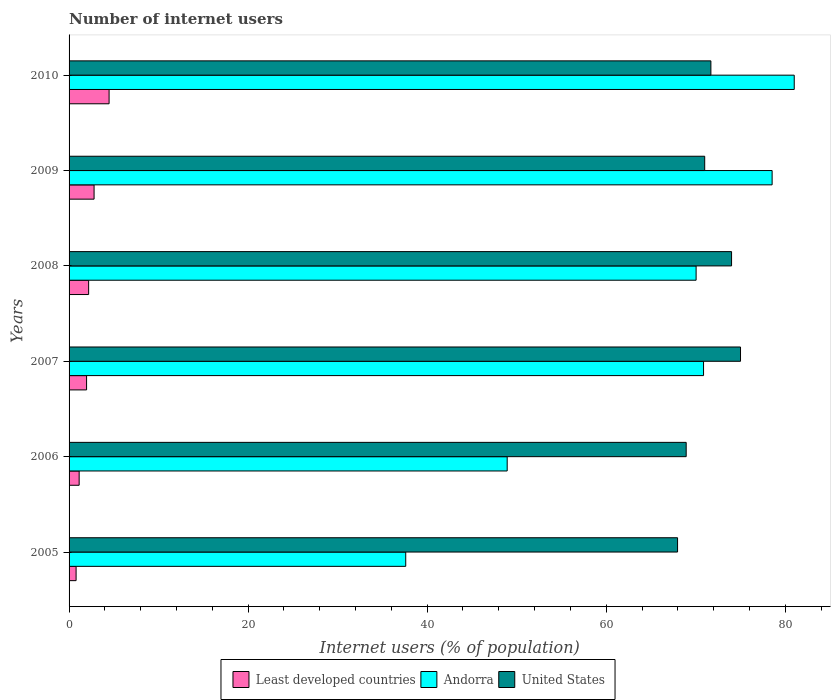Are the number of bars on each tick of the Y-axis equal?
Make the answer very short. Yes. How many bars are there on the 4th tick from the top?
Offer a very short reply. 3. How many bars are there on the 6th tick from the bottom?
Make the answer very short. 3. What is the label of the 6th group of bars from the top?
Provide a succinct answer. 2005. What is the number of internet users in Andorra in 2010?
Ensure brevity in your answer.  81. Across all years, what is the minimum number of internet users in Andorra?
Give a very brief answer. 37.61. What is the total number of internet users in United States in the graph?
Offer a very short reply. 428.59. What is the difference between the number of internet users in United States in 2006 and that in 2009?
Your answer should be compact. -2.07. What is the difference between the number of internet users in United States in 2010 and the number of internet users in Andorra in 2006?
Your answer should be compact. 22.75. What is the average number of internet users in Andorra per year?
Keep it short and to the point. 64.5. In the year 2008, what is the difference between the number of internet users in Andorra and number of internet users in United States?
Ensure brevity in your answer.  -3.96. In how many years, is the number of internet users in Andorra greater than 56 %?
Your answer should be very brief. 4. What is the ratio of the number of internet users in United States in 2009 to that in 2010?
Your answer should be very brief. 0.99. Is the difference between the number of internet users in Andorra in 2005 and 2010 greater than the difference between the number of internet users in United States in 2005 and 2010?
Keep it short and to the point. No. What is the difference between the highest and the lowest number of internet users in United States?
Provide a short and direct response. 7.03. In how many years, is the number of internet users in Andorra greater than the average number of internet users in Andorra taken over all years?
Provide a succinct answer. 4. Is the sum of the number of internet users in Least developed countries in 2007 and 2009 greater than the maximum number of internet users in Andorra across all years?
Give a very brief answer. No. What does the 2nd bar from the top in 2009 represents?
Make the answer very short. Andorra. What does the 1st bar from the bottom in 2007 represents?
Make the answer very short. Least developed countries. Are all the bars in the graph horizontal?
Make the answer very short. Yes. What is the difference between two consecutive major ticks on the X-axis?
Keep it short and to the point. 20. Are the values on the major ticks of X-axis written in scientific E-notation?
Your answer should be compact. No. Does the graph contain grids?
Give a very brief answer. No. Where does the legend appear in the graph?
Keep it short and to the point. Bottom center. How many legend labels are there?
Offer a terse response. 3. What is the title of the graph?
Provide a short and direct response. Number of internet users. What is the label or title of the X-axis?
Offer a very short reply. Internet users (% of population). What is the Internet users (% of population) in Least developed countries in 2005?
Provide a short and direct response. 0.78. What is the Internet users (% of population) of Andorra in 2005?
Provide a succinct answer. 37.61. What is the Internet users (% of population) of United States in 2005?
Ensure brevity in your answer.  67.97. What is the Internet users (% of population) in Least developed countries in 2006?
Your answer should be very brief. 1.13. What is the Internet users (% of population) in Andorra in 2006?
Your response must be concise. 48.94. What is the Internet users (% of population) in United States in 2006?
Make the answer very short. 68.93. What is the Internet users (% of population) in Least developed countries in 2007?
Keep it short and to the point. 1.96. What is the Internet users (% of population) in Andorra in 2007?
Offer a very short reply. 70.87. What is the Internet users (% of population) in Least developed countries in 2008?
Your response must be concise. 2.19. What is the Internet users (% of population) of Andorra in 2008?
Give a very brief answer. 70.04. What is the Internet users (% of population) of Least developed countries in 2009?
Offer a very short reply. 2.79. What is the Internet users (% of population) in Andorra in 2009?
Ensure brevity in your answer.  78.53. What is the Internet users (% of population) of United States in 2009?
Offer a very short reply. 71. What is the Internet users (% of population) in Least developed countries in 2010?
Your answer should be compact. 4.47. What is the Internet users (% of population) in United States in 2010?
Provide a short and direct response. 71.69. Across all years, what is the maximum Internet users (% of population) of Least developed countries?
Offer a terse response. 4.47. Across all years, what is the maximum Internet users (% of population) of Andorra?
Provide a short and direct response. 81. Across all years, what is the minimum Internet users (% of population) of Least developed countries?
Keep it short and to the point. 0.78. Across all years, what is the minimum Internet users (% of population) of Andorra?
Offer a very short reply. 37.61. Across all years, what is the minimum Internet users (% of population) in United States?
Offer a terse response. 67.97. What is the total Internet users (% of population) of Least developed countries in the graph?
Your answer should be compact. 13.32. What is the total Internet users (% of population) of Andorra in the graph?
Offer a terse response. 386.98. What is the total Internet users (% of population) of United States in the graph?
Your answer should be very brief. 428.59. What is the difference between the Internet users (% of population) of Least developed countries in 2005 and that in 2006?
Offer a terse response. -0.34. What is the difference between the Internet users (% of population) in Andorra in 2005 and that in 2006?
Offer a very short reply. -11.33. What is the difference between the Internet users (% of population) in United States in 2005 and that in 2006?
Your answer should be compact. -0.96. What is the difference between the Internet users (% of population) in Least developed countries in 2005 and that in 2007?
Give a very brief answer. -1.17. What is the difference between the Internet users (% of population) in Andorra in 2005 and that in 2007?
Ensure brevity in your answer.  -33.26. What is the difference between the Internet users (% of population) of United States in 2005 and that in 2007?
Give a very brief answer. -7.03. What is the difference between the Internet users (% of population) of Least developed countries in 2005 and that in 2008?
Offer a terse response. -1.4. What is the difference between the Internet users (% of population) in Andorra in 2005 and that in 2008?
Provide a short and direct response. -32.43. What is the difference between the Internet users (% of population) of United States in 2005 and that in 2008?
Ensure brevity in your answer.  -6.03. What is the difference between the Internet users (% of population) of Least developed countries in 2005 and that in 2009?
Offer a terse response. -2.01. What is the difference between the Internet users (% of population) in Andorra in 2005 and that in 2009?
Keep it short and to the point. -40.92. What is the difference between the Internet users (% of population) of United States in 2005 and that in 2009?
Make the answer very short. -3.03. What is the difference between the Internet users (% of population) of Least developed countries in 2005 and that in 2010?
Keep it short and to the point. -3.69. What is the difference between the Internet users (% of population) of Andorra in 2005 and that in 2010?
Your response must be concise. -43.39. What is the difference between the Internet users (% of population) in United States in 2005 and that in 2010?
Ensure brevity in your answer.  -3.72. What is the difference between the Internet users (% of population) of Least developed countries in 2006 and that in 2007?
Provide a short and direct response. -0.83. What is the difference between the Internet users (% of population) of Andorra in 2006 and that in 2007?
Give a very brief answer. -21.93. What is the difference between the Internet users (% of population) of United States in 2006 and that in 2007?
Your response must be concise. -6.07. What is the difference between the Internet users (% of population) of Least developed countries in 2006 and that in 2008?
Offer a very short reply. -1.06. What is the difference between the Internet users (% of population) of Andorra in 2006 and that in 2008?
Your answer should be compact. -21.1. What is the difference between the Internet users (% of population) of United States in 2006 and that in 2008?
Offer a very short reply. -5.07. What is the difference between the Internet users (% of population) of Least developed countries in 2006 and that in 2009?
Offer a very short reply. -1.67. What is the difference between the Internet users (% of population) of Andorra in 2006 and that in 2009?
Your answer should be very brief. -29.59. What is the difference between the Internet users (% of population) of United States in 2006 and that in 2009?
Provide a short and direct response. -2.07. What is the difference between the Internet users (% of population) in Least developed countries in 2006 and that in 2010?
Ensure brevity in your answer.  -3.34. What is the difference between the Internet users (% of population) in Andorra in 2006 and that in 2010?
Your answer should be compact. -32.06. What is the difference between the Internet users (% of population) in United States in 2006 and that in 2010?
Provide a short and direct response. -2.76. What is the difference between the Internet users (% of population) in Least developed countries in 2007 and that in 2008?
Your response must be concise. -0.23. What is the difference between the Internet users (% of population) in Andorra in 2007 and that in 2008?
Provide a succinct answer. 0.83. What is the difference between the Internet users (% of population) in Least developed countries in 2007 and that in 2009?
Provide a succinct answer. -0.84. What is the difference between the Internet users (% of population) of Andorra in 2007 and that in 2009?
Your answer should be very brief. -7.66. What is the difference between the Internet users (% of population) in Least developed countries in 2007 and that in 2010?
Offer a very short reply. -2.52. What is the difference between the Internet users (% of population) in Andorra in 2007 and that in 2010?
Make the answer very short. -10.13. What is the difference between the Internet users (% of population) in United States in 2007 and that in 2010?
Offer a terse response. 3.31. What is the difference between the Internet users (% of population) of Least developed countries in 2008 and that in 2009?
Give a very brief answer. -0.61. What is the difference between the Internet users (% of population) of Andorra in 2008 and that in 2009?
Offer a terse response. -8.49. What is the difference between the Internet users (% of population) of Least developed countries in 2008 and that in 2010?
Provide a succinct answer. -2.29. What is the difference between the Internet users (% of population) in Andorra in 2008 and that in 2010?
Your answer should be compact. -10.96. What is the difference between the Internet users (% of population) in United States in 2008 and that in 2010?
Make the answer very short. 2.31. What is the difference between the Internet users (% of population) of Least developed countries in 2009 and that in 2010?
Ensure brevity in your answer.  -1.68. What is the difference between the Internet users (% of population) in Andorra in 2009 and that in 2010?
Keep it short and to the point. -2.47. What is the difference between the Internet users (% of population) of United States in 2009 and that in 2010?
Give a very brief answer. -0.69. What is the difference between the Internet users (% of population) of Least developed countries in 2005 and the Internet users (% of population) of Andorra in 2006?
Keep it short and to the point. -48.15. What is the difference between the Internet users (% of population) of Least developed countries in 2005 and the Internet users (% of population) of United States in 2006?
Provide a succinct answer. -68.15. What is the difference between the Internet users (% of population) of Andorra in 2005 and the Internet users (% of population) of United States in 2006?
Your answer should be compact. -31.33. What is the difference between the Internet users (% of population) in Least developed countries in 2005 and the Internet users (% of population) in Andorra in 2007?
Your response must be concise. -70.09. What is the difference between the Internet users (% of population) of Least developed countries in 2005 and the Internet users (% of population) of United States in 2007?
Keep it short and to the point. -74.22. What is the difference between the Internet users (% of population) in Andorra in 2005 and the Internet users (% of population) in United States in 2007?
Your response must be concise. -37.39. What is the difference between the Internet users (% of population) in Least developed countries in 2005 and the Internet users (% of population) in Andorra in 2008?
Make the answer very short. -69.26. What is the difference between the Internet users (% of population) in Least developed countries in 2005 and the Internet users (% of population) in United States in 2008?
Ensure brevity in your answer.  -73.22. What is the difference between the Internet users (% of population) of Andorra in 2005 and the Internet users (% of population) of United States in 2008?
Provide a succinct answer. -36.39. What is the difference between the Internet users (% of population) of Least developed countries in 2005 and the Internet users (% of population) of Andorra in 2009?
Offer a very short reply. -77.75. What is the difference between the Internet users (% of population) in Least developed countries in 2005 and the Internet users (% of population) in United States in 2009?
Give a very brief answer. -70.22. What is the difference between the Internet users (% of population) of Andorra in 2005 and the Internet users (% of population) of United States in 2009?
Give a very brief answer. -33.39. What is the difference between the Internet users (% of population) of Least developed countries in 2005 and the Internet users (% of population) of Andorra in 2010?
Keep it short and to the point. -80.22. What is the difference between the Internet users (% of population) of Least developed countries in 2005 and the Internet users (% of population) of United States in 2010?
Provide a short and direct response. -70.91. What is the difference between the Internet users (% of population) of Andorra in 2005 and the Internet users (% of population) of United States in 2010?
Your answer should be compact. -34.08. What is the difference between the Internet users (% of population) in Least developed countries in 2006 and the Internet users (% of population) in Andorra in 2007?
Your response must be concise. -69.74. What is the difference between the Internet users (% of population) in Least developed countries in 2006 and the Internet users (% of population) in United States in 2007?
Your answer should be compact. -73.87. What is the difference between the Internet users (% of population) in Andorra in 2006 and the Internet users (% of population) in United States in 2007?
Keep it short and to the point. -26.06. What is the difference between the Internet users (% of population) in Least developed countries in 2006 and the Internet users (% of population) in Andorra in 2008?
Your answer should be very brief. -68.91. What is the difference between the Internet users (% of population) of Least developed countries in 2006 and the Internet users (% of population) of United States in 2008?
Provide a short and direct response. -72.87. What is the difference between the Internet users (% of population) of Andorra in 2006 and the Internet users (% of population) of United States in 2008?
Keep it short and to the point. -25.06. What is the difference between the Internet users (% of population) in Least developed countries in 2006 and the Internet users (% of population) in Andorra in 2009?
Provide a succinct answer. -77.4. What is the difference between the Internet users (% of population) of Least developed countries in 2006 and the Internet users (% of population) of United States in 2009?
Give a very brief answer. -69.87. What is the difference between the Internet users (% of population) in Andorra in 2006 and the Internet users (% of population) in United States in 2009?
Provide a short and direct response. -22.06. What is the difference between the Internet users (% of population) of Least developed countries in 2006 and the Internet users (% of population) of Andorra in 2010?
Offer a terse response. -79.87. What is the difference between the Internet users (% of population) in Least developed countries in 2006 and the Internet users (% of population) in United States in 2010?
Offer a very short reply. -70.56. What is the difference between the Internet users (% of population) in Andorra in 2006 and the Internet users (% of population) in United States in 2010?
Ensure brevity in your answer.  -22.75. What is the difference between the Internet users (% of population) in Least developed countries in 2007 and the Internet users (% of population) in Andorra in 2008?
Give a very brief answer. -68.08. What is the difference between the Internet users (% of population) of Least developed countries in 2007 and the Internet users (% of population) of United States in 2008?
Your answer should be very brief. -72.04. What is the difference between the Internet users (% of population) in Andorra in 2007 and the Internet users (% of population) in United States in 2008?
Provide a short and direct response. -3.13. What is the difference between the Internet users (% of population) in Least developed countries in 2007 and the Internet users (% of population) in Andorra in 2009?
Provide a succinct answer. -76.57. What is the difference between the Internet users (% of population) of Least developed countries in 2007 and the Internet users (% of population) of United States in 2009?
Offer a very short reply. -69.04. What is the difference between the Internet users (% of population) in Andorra in 2007 and the Internet users (% of population) in United States in 2009?
Your answer should be very brief. -0.13. What is the difference between the Internet users (% of population) of Least developed countries in 2007 and the Internet users (% of population) of Andorra in 2010?
Keep it short and to the point. -79.04. What is the difference between the Internet users (% of population) in Least developed countries in 2007 and the Internet users (% of population) in United States in 2010?
Your answer should be very brief. -69.73. What is the difference between the Internet users (% of population) in Andorra in 2007 and the Internet users (% of population) in United States in 2010?
Offer a terse response. -0.82. What is the difference between the Internet users (% of population) of Least developed countries in 2008 and the Internet users (% of population) of Andorra in 2009?
Your answer should be compact. -76.34. What is the difference between the Internet users (% of population) in Least developed countries in 2008 and the Internet users (% of population) in United States in 2009?
Your response must be concise. -68.81. What is the difference between the Internet users (% of population) in Andorra in 2008 and the Internet users (% of population) in United States in 2009?
Provide a short and direct response. -0.96. What is the difference between the Internet users (% of population) of Least developed countries in 2008 and the Internet users (% of population) of Andorra in 2010?
Your answer should be very brief. -78.81. What is the difference between the Internet users (% of population) of Least developed countries in 2008 and the Internet users (% of population) of United States in 2010?
Your response must be concise. -69.5. What is the difference between the Internet users (% of population) in Andorra in 2008 and the Internet users (% of population) in United States in 2010?
Ensure brevity in your answer.  -1.65. What is the difference between the Internet users (% of population) in Least developed countries in 2009 and the Internet users (% of population) in Andorra in 2010?
Your response must be concise. -78.21. What is the difference between the Internet users (% of population) in Least developed countries in 2009 and the Internet users (% of population) in United States in 2010?
Your answer should be very brief. -68.9. What is the difference between the Internet users (% of population) in Andorra in 2009 and the Internet users (% of population) in United States in 2010?
Your answer should be compact. 6.84. What is the average Internet users (% of population) of Least developed countries per year?
Ensure brevity in your answer.  2.22. What is the average Internet users (% of population) in Andorra per year?
Provide a short and direct response. 64.5. What is the average Internet users (% of population) in United States per year?
Your answer should be very brief. 71.43. In the year 2005, what is the difference between the Internet users (% of population) of Least developed countries and Internet users (% of population) of Andorra?
Ensure brevity in your answer.  -36.82. In the year 2005, what is the difference between the Internet users (% of population) in Least developed countries and Internet users (% of population) in United States?
Provide a succinct answer. -67.18. In the year 2005, what is the difference between the Internet users (% of population) in Andorra and Internet users (% of population) in United States?
Keep it short and to the point. -30.36. In the year 2006, what is the difference between the Internet users (% of population) of Least developed countries and Internet users (% of population) of Andorra?
Ensure brevity in your answer.  -47.81. In the year 2006, what is the difference between the Internet users (% of population) in Least developed countries and Internet users (% of population) in United States?
Offer a very short reply. -67.8. In the year 2006, what is the difference between the Internet users (% of population) in Andorra and Internet users (% of population) in United States?
Provide a short and direct response. -19.99. In the year 2007, what is the difference between the Internet users (% of population) in Least developed countries and Internet users (% of population) in Andorra?
Offer a terse response. -68.91. In the year 2007, what is the difference between the Internet users (% of population) of Least developed countries and Internet users (% of population) of United States?
Provide a succinct answer. -73.04. In the year 2007, what is the difference between the Internet users (% of population) of Andorra and Internet users (% of population) of United States?
Provide a short and direct response. -4.13. In the year 2008, what is the difference between the Internet users (% of population) in Least developed countries and Internet users (% of population) in Andorra?
Offer a terse response. -67.85. In the year 2008, what is the difference between the Internet users (% of population) in Least developed countries and Internet users (% of population) in United States?
Give a very brief answer. -71.81. In the year 2008, what is the difference between the Internet users (% of population) in Andorra and Internet users (% of population) in United States?
Your answer should be compact. -3.96. In the year 2009, what is the difference between the Internet users (% of population) in Least developed countries and Internet users (% of population) in Andorra?
Keep it short and to the point. -75.74. In the year 2009, what is the difference between the Internet users (% of population) of Least developed countries and Internet users (% of population) of United States?
Keep it short and to the point. -68.21. In the year 2009, what is the difference between the Internet users (% of population) of Andorra and Internet users (% of population) of United States?
Ensure brevity in your answer.  7.53. In the year 2010, what is the difference between the Internet users (% of population) of Least developed countries and Internet users (% of population) of Andorra?
Offer a terse response. -76.53. In the year 2010, what is the difference between the Internet users (% of population) of Least developed countries and Internet users (% of population) of United States?
Provide a succinct answer. -67.22. In the year 2010, what is the difference between the Internet users (% of population) in Andorra and Internet users (% of population) in United States?
Ensure brevity in your answer.  9.31. What is the ratio of the Internet users (% of population) in Least developed countries in 2005 to that in 2006?
Provide a short and direct response. 0.7. What is the ratio of the Internet users (% of population) of Andorra in 2005 to that in 2006?
Your answer should be very brief. 0.77. What is the ratio of the Internet users (% of population) of Least developed countries in 2005 to that in 2007?
Give a very brief answer. 0.4. What is the ratio of the Internet users (% of population) of Andorra in 2005 to that in 2007?
Your answer should be compact. 0.53. What is the ratio of the Internet users (% of population) of United States in 2005 to that in 2007?
Offer a terse response. 0.91. What is the ratio of the Internet users (% of population) of Least developed countries in 2005 to that in 2008?
Provide a succinct answer. 0.36. What is the ratio of the Internet users (% of population) of Andorra in 2005 to that in 2008?
Offer a very short reply. 0.54. What is the ratio of the Internet users (% of population) of United States in 2005 to that in 2008?
Keep it short and to the point. 0.92. What is the ratio of the Internet users (% of population) of Least developed countries in 2005 to that in 2009?
Your answer should be compact. 0.28. What is the ratio of the Internet users (% of population) of Andorra in 2005 to that in 2009?
Keep it short and to the point. 0.48. What is the ratio of the Internet users (% of population) of United States in 2005 to that in 2009?
Your answer should be compact. 0.96. What is the ratio of the Internet users (% of population) in Least developed countries in 2005 to that in 2010?
Provide a succinct answer. 0.18. What is the ratio of the Internet users (% of population) in Andorra in 2005 to that in 2010?
Keep it short and to the point. 0.46. What is the ratio of the Internet users (% of population) of United States in 2005 to that in 2010?
Keep it short and to the point. 0.95. What is the ratio of the Internet users (% of population) of Least developed countries in 2006 to that in 2007?
Give a very brief answer. 0.58. What is the ratio of the Internet users (% of population) in Andorra in 2006 to that in 2007?
Your answer should be very brief. 0.69. What is the ratio of the Internet users (% of population) of United States in 2006 to that in 2007?
Give a very brief answer. 0.92. What is the ratio of the Internet users (% of population) of Least developed countries in 2006 to that in 2008?
Make the answer very short. 0.52. What is the ratio of the Internet users (% of population) of Andorra in 2006 to that in 2008?
Your answer should be very brief. 0.7. What is the ratio of the Internet users (% of population) of United States in 2006 to that in 2008?
Offer a terse response. 0.93. What is the ratio of the Internet users (% of population) of Least developed countries in 2006 to that in 2009?
Your answer should be compact. 0.4. What is the ratio of the Internet users (% of population) of Andorra in 2006 to that in 2009?
Ensure brevity in your answer.  0.62. What is the ratio of the Internet users (% of population) in United States in 2006 to that in 2009?
Provide a succinct answer. 0.97. What is the ratio of the Internet users (% of population) in Least developed countries in 2006 to that in 2010?
Keep it short and to the point. 0.25. What is the ratio of the Internet users (% of population) of Andorra in 2006 to that in 2010?
Ensure brevity in your answer.  0.6. What is the ratio of the Internet users (% of population) in United States in 2006 to that in 2010?
Your response must be concise. 0.96. What is the ratio of the Internet users (% of population) in Least developed countries in 2007 to that in 2008?
Offer a terse response. 0.89. What is the ratio of the Internet users (% of population) in Andorra in 2007 to that in 2008?
Your answer should be very brief. 1.01. What is the ratio of the Internet users (% of population) in United States in 2007 to that in 2008?
Give a very brief answer. 1.01. What is the ratio of the Internet users (% of population) in Least developed countries in 2007 to that in 2009?
Provide a succinct answer. 0.7. What is the ratio of the Internet users (% of population) in Andorra in 2007 to that in 2009?
Keep it short and to the point. 0.9. What is the ratio of the Internet users (% of population) in United States in 2007 to that in 2009?
Keep it short and to the point. 1.06. What is the ratio of the Internet users (% of population) of Least developed countries in 2007 to that in 2010?
Your answer should be very brief. 0.44. What is the ratio of the Internet users (% of population) in Andorra in 2007 to that in 2010?
Provide a succinct answer. 0.87. What is the ratio of the Internet users (% of population) of United States in 2007 to that in 2010?
Provide a succinct answer. 1.05. What is the ratio of the Internet users (% of population) of Least developed countries in 2008 to that in 2009?
Give a very brief answer. 0.78. What is the ratio of the Internet users (% of population) of Andorra in 2008 to that in 2009?
Give a very brief answer. 0.89. What is the ratio of the Internet users (% of population) in United States in 2008 to that in 2009?
Your response must be concise. 1.04. What is the ratio of the Internet users (% of population) in Least developed countries in 2008 to that in 2010?
Your response must be concise. 0.49. What is the ratio of the Internet users (% of population) in Andorra in 2008 to that in 2010?
Provide a short and direct response. 0.86. What is the ratio of the Internet users (% of population) in United States in 2008 to that in 2010?
Offer a very short reply. 1.03. What is the ratio of the Internet users (% of population) in Least developed countries in 2009 to that in 2010?
Offer a very short reply. 0.62. What is the ratio of the Internet users (% of population) of Andorra in 2009 to that in 2010?
Your response must be concise. 0.97. What is the ratio of the Internet users (% of population) of United States in 2009 to that in 2010?
Provide a succinct answer. 0.99. What is the difference between the highest and the second highest Internet users (% of population) of Least developed countries?
Ensure brevity in your answer.  1.68. What is the difference between the highest and the second highest Internet users (% of population) of Andorra?
Your answer should be compact. 2.47. What is the difference between the highest and the second highest Internet users (% of population) in United States?
Provide a succinct answer. 1. What is the difference between the highest and the lowest Internet users (% of population) of Least developed countries?
Keep it short and to the point. 3.69. What is the difference between the highest and the lowest Internet users (% of population) of Andorra?
Provide a short and direct response. 43.39. What is the difference between the highest and the lowest Internet users (% of population) of United States?
Your answer should be very brief. 7.03. 